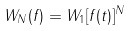Convert formula to latex. <formula><loc_0><loc_0><loc_500><loc_500>W _ { N } ( f ) = W _ { 1 } [ f ( t ) ] ^ { N }</formula> 